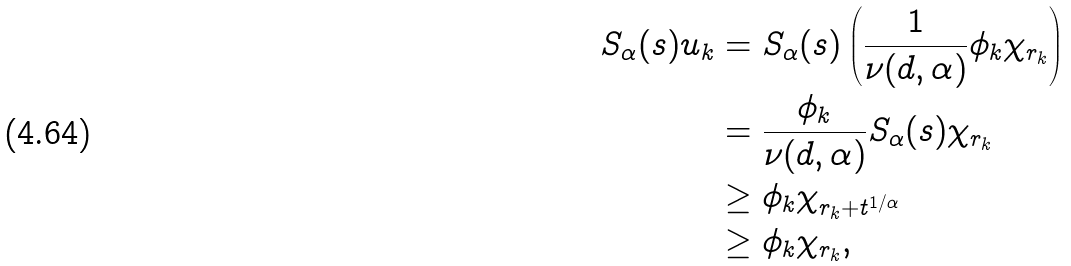Convert formula to latex. <formula><loc_0><loc_0><loc_500><loc_500>S _ { \alpha } ( s ) u _ { k } & = S _ { \alpha } ( s ) \left ( \frac { 1 } { \nu ( d , \alpha ) } \phi _ { k } \chi _ { r _ { k } } \right ) \\ & = \frac { \phi _ { k } } { \nu ( d , \alpha ) } S _ { \alpha } ( s ) \chi _ { r _ { k } } \\ & \geq \phi _ { k } \chi _ { r _ { k } + t ^ { 1 / \alpha } } \\ & \geq \phi _ { k } \chi _ { r _ { k } } ,</formula> 